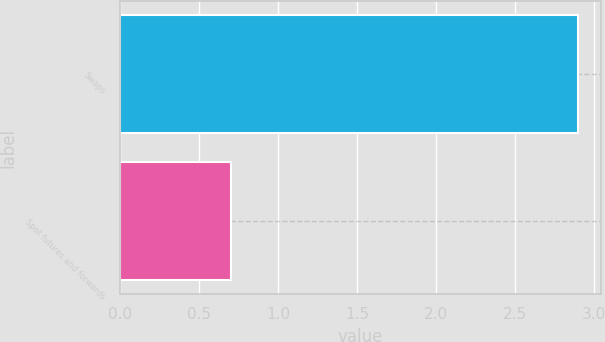Convert chart to OTSL. <chart><loc_0><loc_0><loc_500><loc_500><bar_chart><fcel>Swaps<fcel>Spot futures and forwards<nl><fcel>2.9<fcel>0.7<nl></chart> 